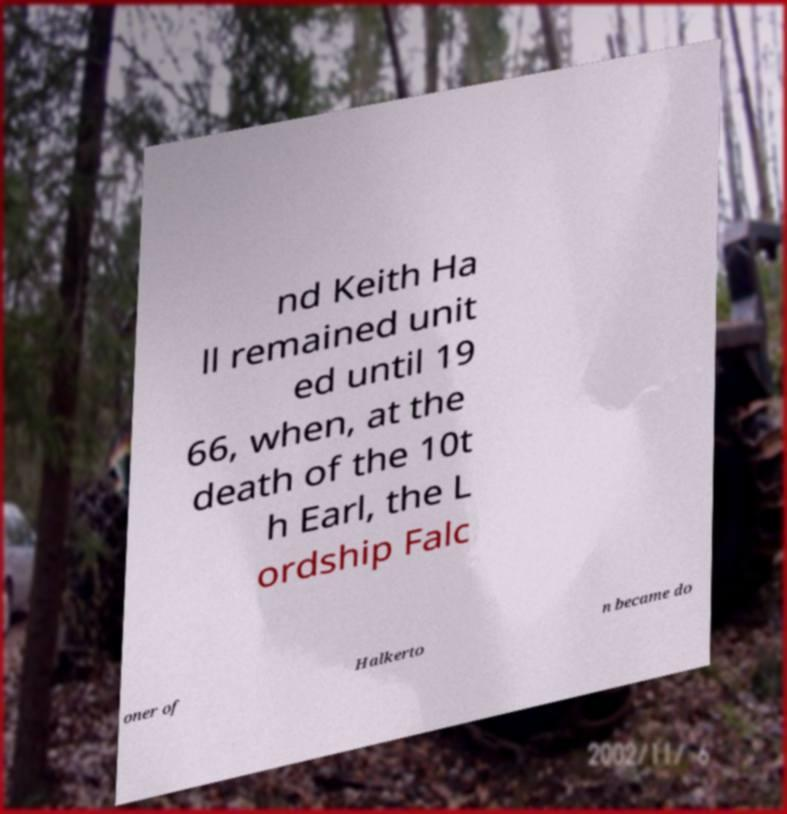Could you extract and type out the text from this image? nd Keith Ha ll remained unit ed until 19 66, when, at the death of the 10t h Earl, the L ordship Falc oner of Halkerto n became do 